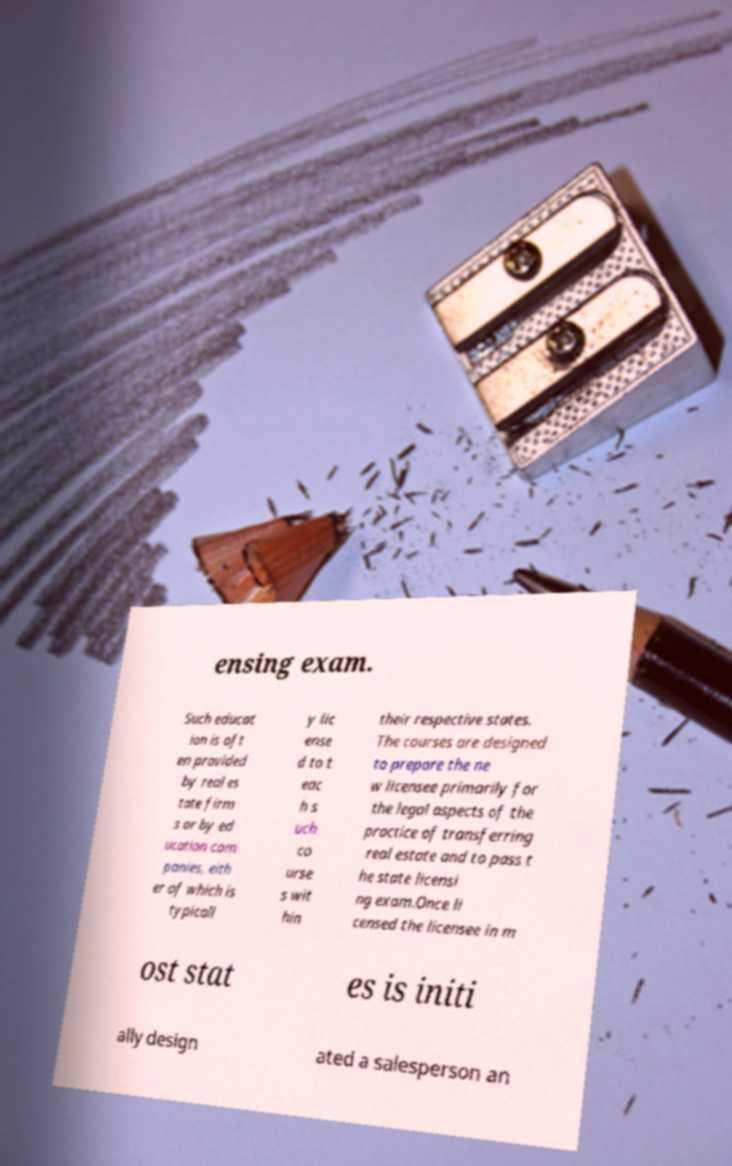Can you read and provide the text displayed in the image?This photo seems to have some interesting text. Can you extract and type it out for me? ensing exam. Such educat ion is oft en provided by real es tate firm s or by ed ucation com panies, eith er of which is typicall y lic ense d to t eac h s uch co urse s wit hin their respective states. The courses are designed to prepare the ne w licensee primarily for the legal aspects of the practice of transferring real estate and to pass t he state licensi ng exam.Once li censed the licensee in m ost stat es is initi ally design ated a salesperson an 